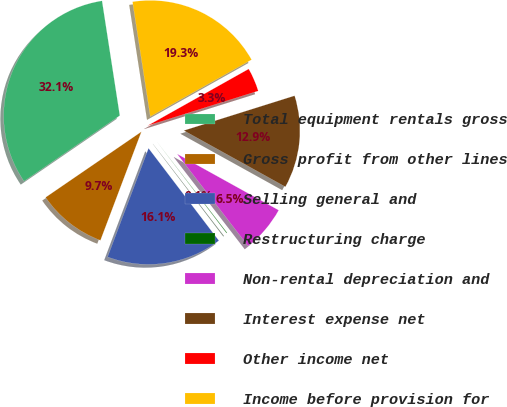<chart> <loc_0><loc_0><loc_500><loc_500><pie_chart><fcel>Total equipment rentals gross<fcel>Gross profit from other lines<fcel>Selling general and<fcel>Restructuring charge<fcel>Non-rental depreciation and<fcel>Interest expense net<fcel>Other income net<fcel>Income before provision for<nl><fcel>32.12%<fcel>9.7%<fcel>16.1%<fcel>0.09%<fcel>6.5%<fcel>12.9%<fcel>3.29%<fcel>19.31%<nl></chart> 